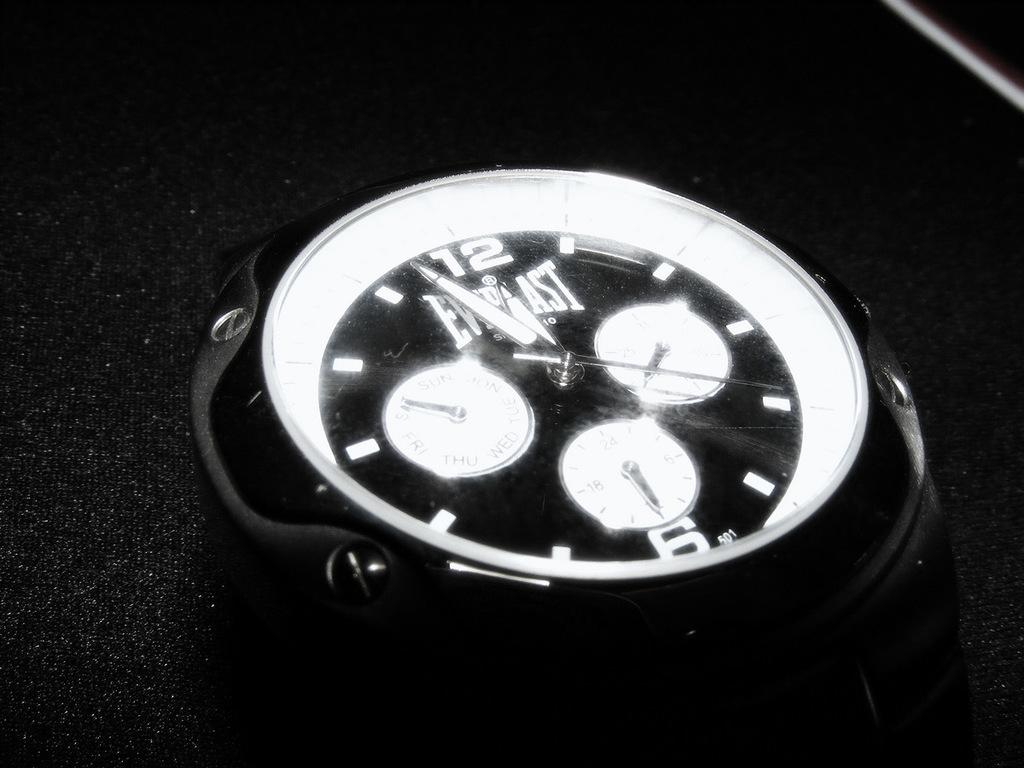What type of watch is this?
Your response must be concise. Everlast. What number is at the top?
Offer a terse response. 12. 